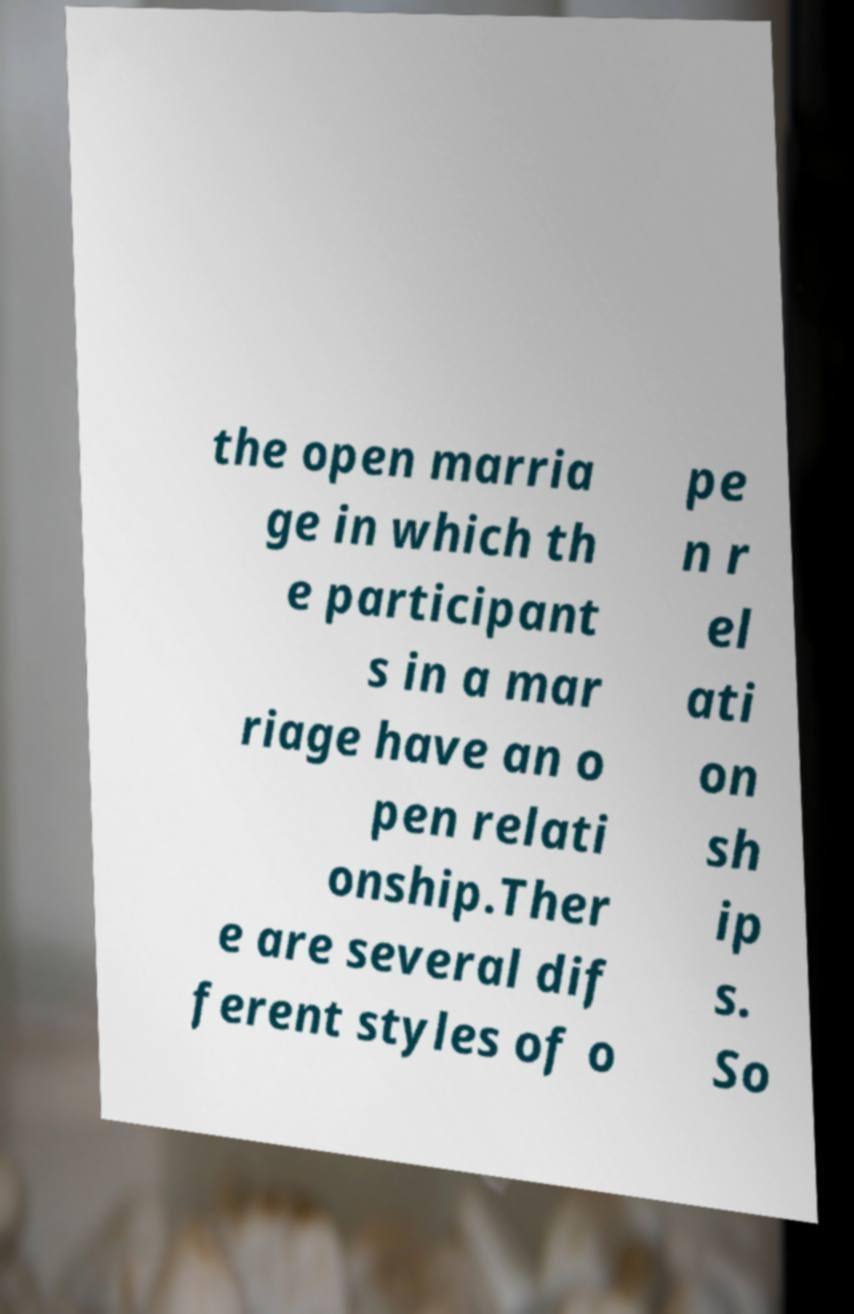I need the written content from this picture converted into text. Can you do that? the open marria ge in which th e participant s in a mar riage have an o pen relati onship.Ther e are several dif ferent styles of o pe n r el ati on sh ip s. So 